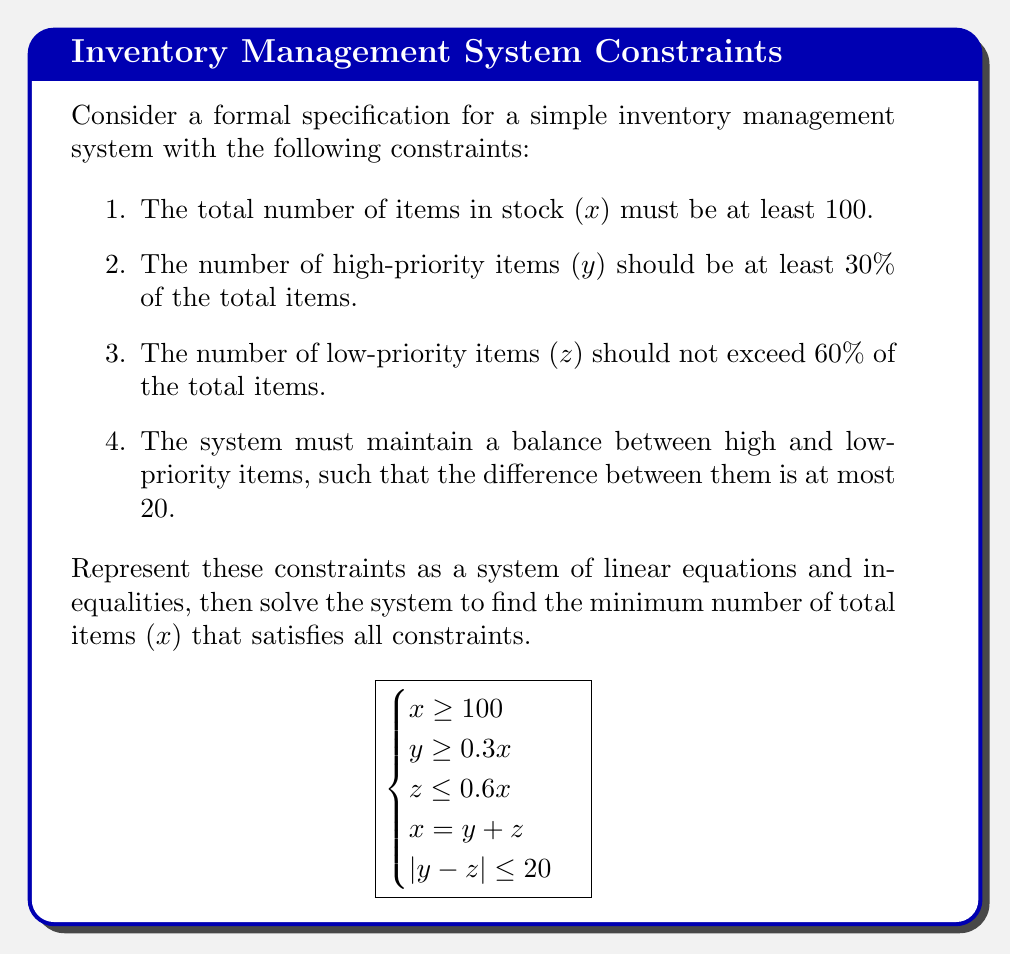Can you answer this question? Let's approach this step-by-step:

1) First, we know that $x \geq 100$. We want to find the minimum $x$, so let's start with $x = 100$.

2) From $y \geq 0.3x$, we get $y \geq 30$ when $x = 100$.

3) From $z \leq 0.6x$, we get $z \leq 60$ when $x = 100$.

4) We know $x = y + z$, so $100 = y + z$.

5) The last constraint $|y - z| \leq 20$ can be written as two inequalities:
   $y - z \leq 20$ and $z - y \leq 20$

6) Let's solve for $y$ and $z$:
   From $100 = y + z$ and $y \geq 30$, we get $z \leq 70$.
   From $100 = y + z$ and $z \leq 60$, we get $y \geq 40$.

7) Now we have:
   $40 \leq y \leq 70$
   $30 \leq z \leq 60$

8) To satisfy $|y - z| \leq 20$, we need to choose values for $y$ and $z$ that are as close as possible while satisfying their individual constraints.

9) The values $y = 50$ and $z = 50$ satisfy all constraints:
   $50 \geq 30$ (30% of 100)
   $50 \leq 60$ (60% of 100)
   $50 + 50 = 100$
   $|50 - 50| = 0 \leq 20$

Therefore, the minimum value of $x$ that satisfies all constraints is 100.
Answer: $x = 100$ 